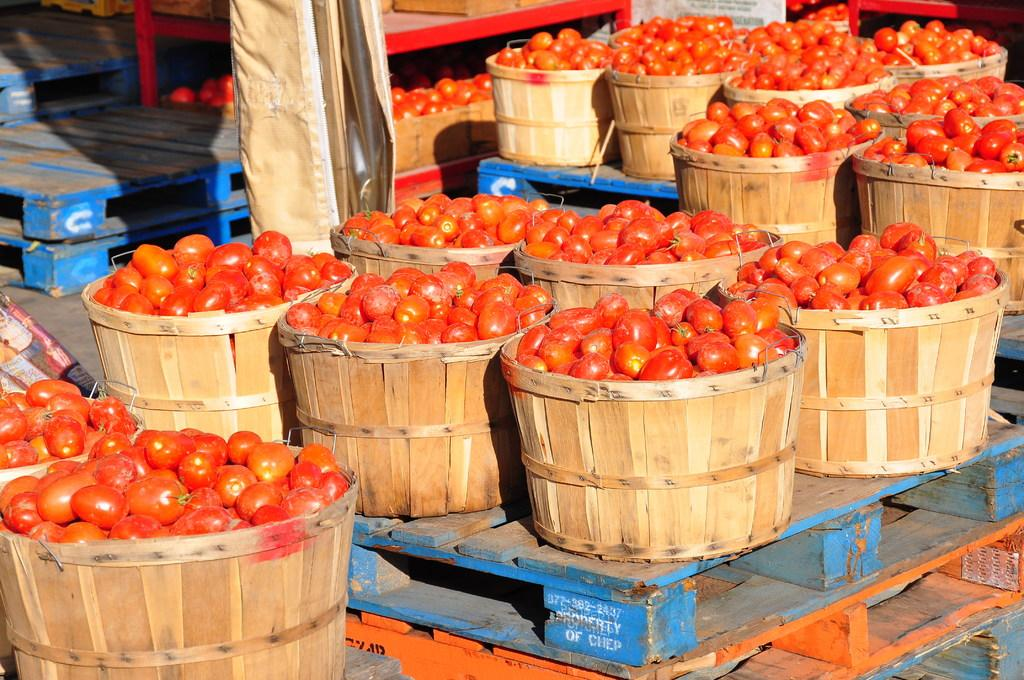What type of objects can be seen in the image? There are pallets and baskets of tomatoes in the image. Can you describe the contents of the baskets? The baskets contain tomatoes. What else is present in the image besides the pallets and tomato baskets? There are some unspecified objects in the image. How many grains of sand can be seen on the pallets in the image? There is no sand present in the image, so it is not possible to determine the number of grains of sand. 